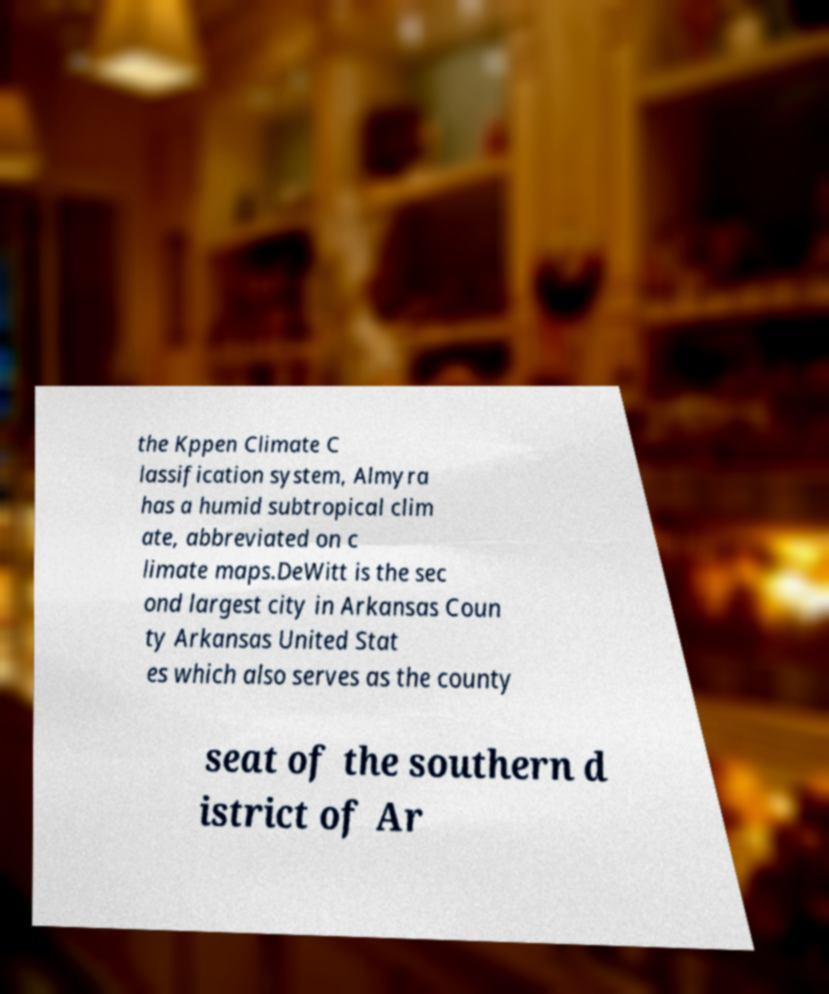I need the written content from this picture converted into text. Can you do that? the Kppen Climate C lassification system, Almyra has a humid subtropical clim ate, abbreviated on c limate maps.DeWitt is the sec ond largest city in Arkansas Coun ty Arkansas United Stat es which also serves as the county seat of the southern d istrict of Ar 